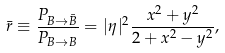<formula> <loc_0><loc_0><loc_500><loc_500>\bar { r } \equiv \frac { P _ { B \rightarrow \bar { B } } } { P _ { B \rightarrow { B } } } = | \eta | ^ { 2 } \frac { x ^ { 2 } + y ^ { 2 } } { 2 + x ^ { 2 } - y ^ { 2 } } ,</formula> 